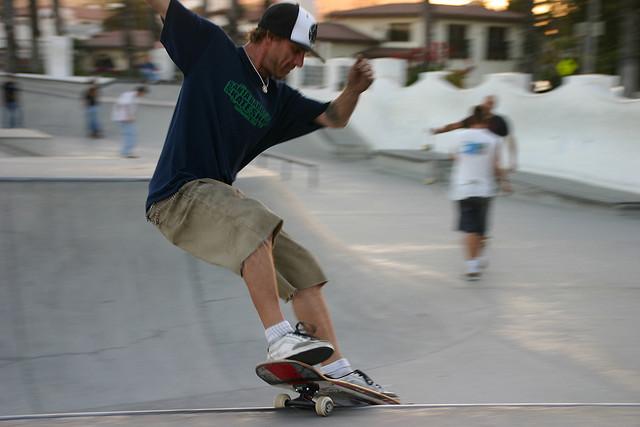Is this skateboarder using safety equipment?
Quick response, please. No. How many people are wearing hats?
Write a very short answer. 1. What sport is being played?
Answer briefly. Skateboarding. Is the guys hat on right?
Give a very brief answer. Yes. What color are the wheels on the skateboard?
Keep it brief. White. What sport is this guy participating in?
Quick response, please. Skateboarding. What color are the mans shorts?
Answer briefly. Khaki. Is the person on the skateboard wearing socks?
Be succinct. Yes. How many men are bald in the picture?
Be succinct. 1. What is the focus of this picture?
Keep it brief. Skateboarder. What does the man in shorts wearing on his feet?
Be succinct. Shoes. Is the skater alone?
Concise answer only. No. 